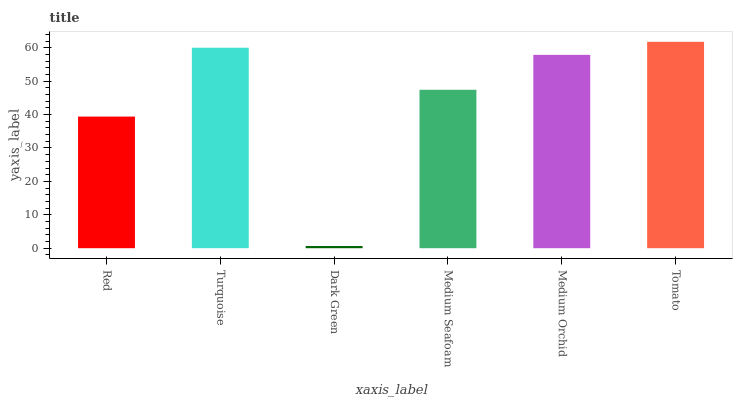Is Turquoise the minimum?
Answer yes or no. No. Is Turquoise the maximum?
Answer yes or no. No. Is Turquoise greater than Red?
Answer yes or no. Yes. Is Red less than Turquoise?
Answer yes or no. Yes. Is Red greater than Turquoise?
Answer yes or no. No. Is Turquoise less than Red?
Answer yes or no. No. Is Medium Orchid the high median?
Answer yes or no. Yes. Is Medium Seafoam the low median?
Answer yes or no. Yes. Is Tomato the high median?
Answer yes or no. No. Is Dark Green the low median?
Answer yes or no. No. 